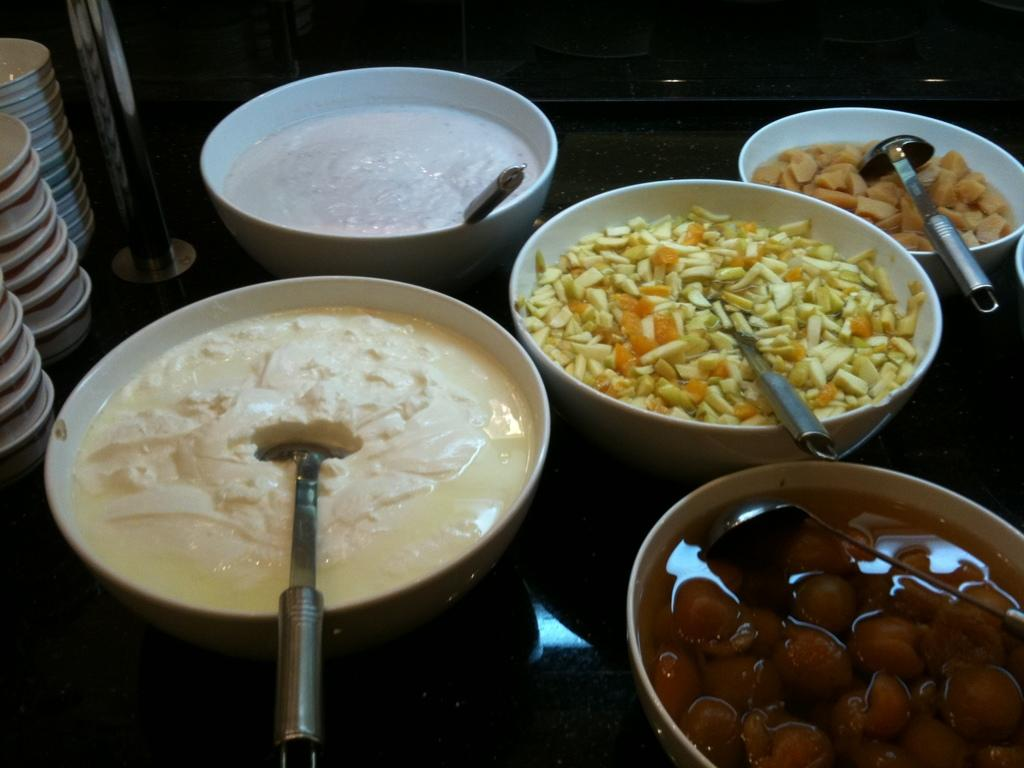What types of items are in the image? There are foods in the image. How are the foods arranged or presented? The foods are placed in bowls. Where are the bowls located? The bowls are placed on a table. Can you tell me how much the soap costs in the image? There is no soap present in the image, so it is not possible to determine its cost. 